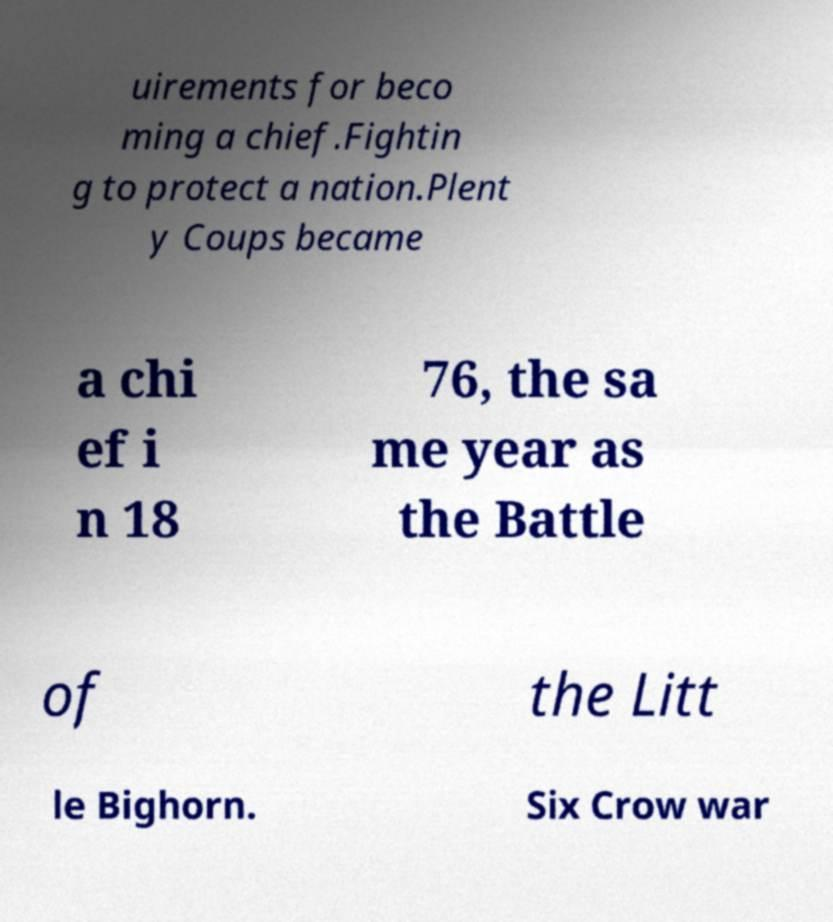Could you extract and type out the text from this image? uirements for beco ming a chief.Fightin g to protect a nation.Plent y Coups became a chi ef i n 18 76, the sa me year as the Battle of the Litt le Bighorn. Six Crow war 